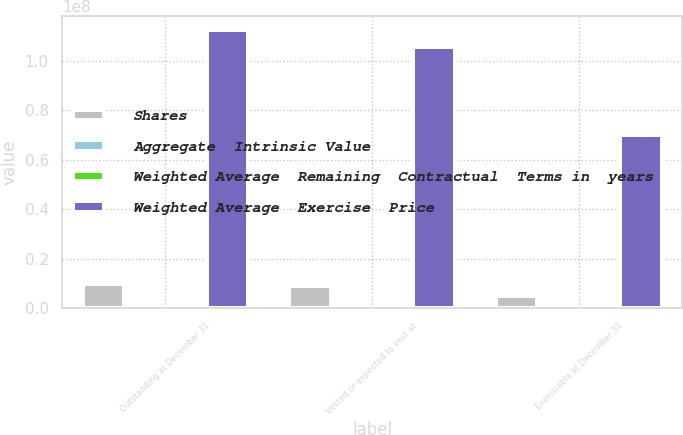<chart> <loc_0><loc_0><loc_500><loc_500><stacked_bar_chart><ecel><fcel>Outstanding at December 31<fcel>Vested or expected to vest at<fcel>Exercisable at December 31<nl><fcel>Shares<fcel>9.72488e+06<fcel>8.7911e+06<fcel>4.8449e+06<nl><fcel>Aggregate  Intrinsic Value<fcel>26.57<fcel>26.13<fcel>23.7<nl><fcel>Weighted Average  Remaining  Contractual  Terms in  years<fcel>6.98<fcel>6.79<fcel>5.29<nl><fcel>Weighted Average  Exercise  Price<fcel>1.12311e+08<fcel>1.05414e+08<fcel>6.98557e+07<nl></chart> 